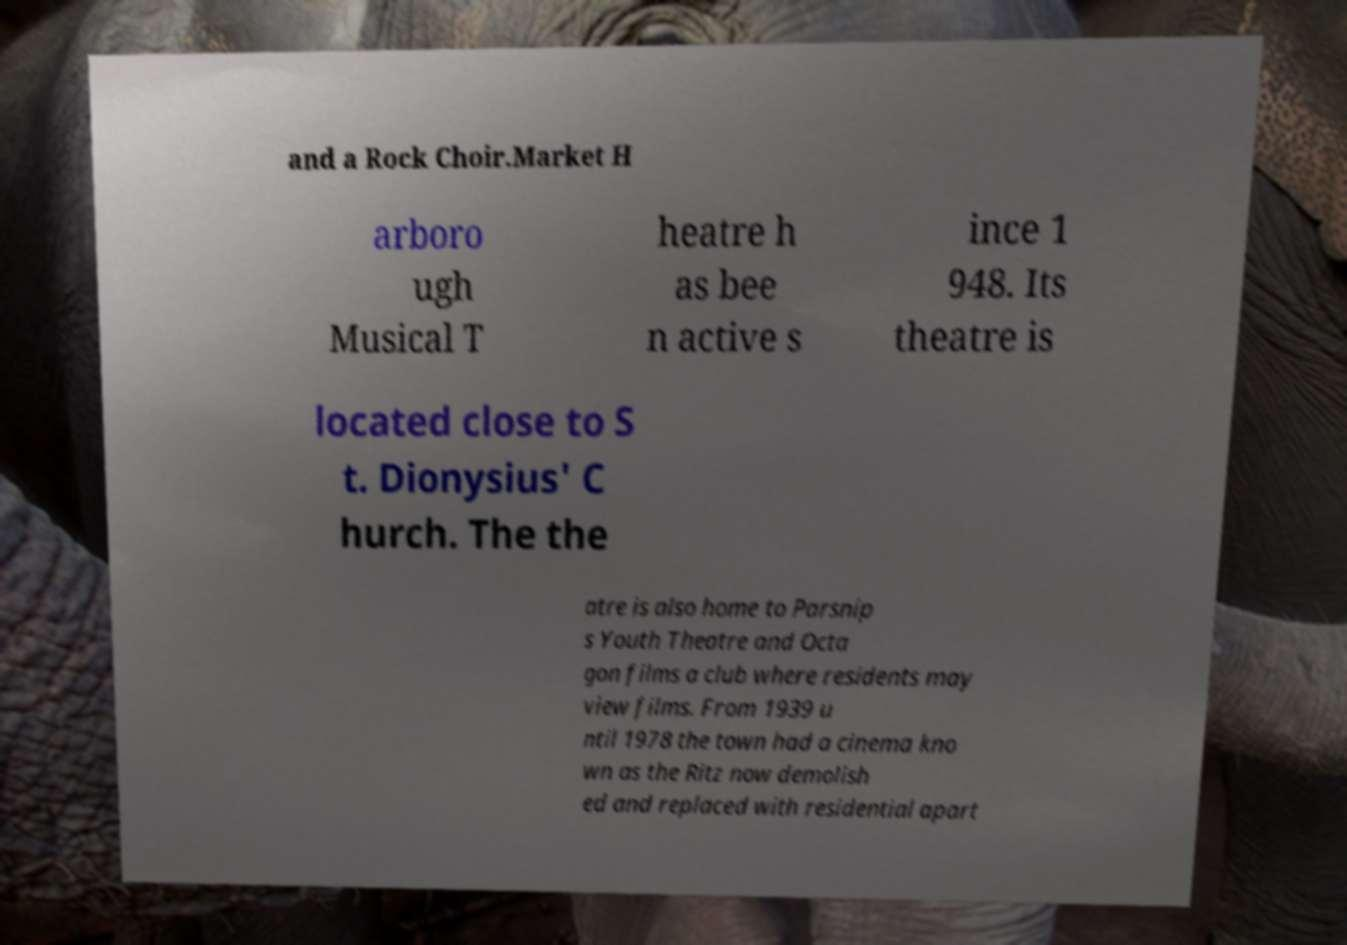Could you extract and type out the text from this image? and a Rock Choir.Market H arboro ugh Musical T heatre h as bee n active s ince 1 948. Its theatre is located close to S t. Dionysius' C hurch. The the atre is also home to Parsnip s Youth Theatre and Octa gon films a club where residents may view films. From 1939 u ntil 1978 the town had a cinema kno wn as the Ritz now demolish ed and replaced with residential apart 